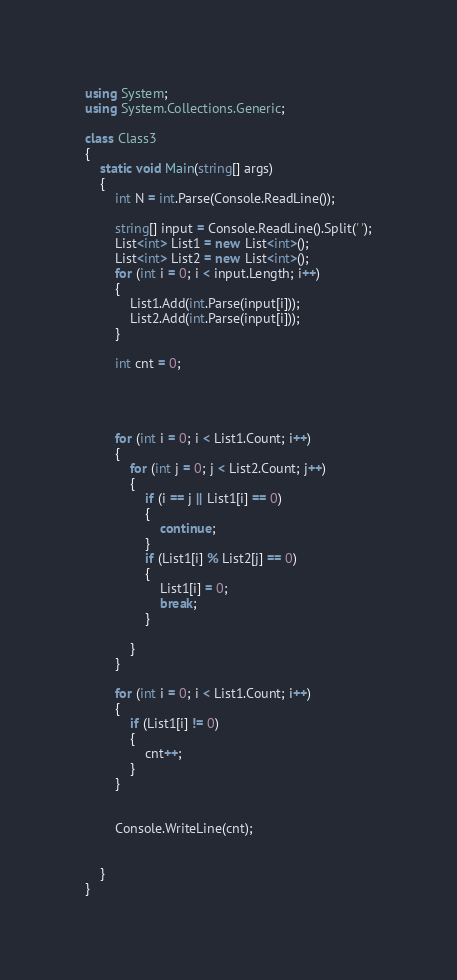Convert code to text. <code><loc_0><loc_0><loc_500><loc_500><_C#_>using System;
using System.Collections.Generic;

class Class3
{
    static void Main(string[] args)
    {
        int N = int.Parse(Console.ReadLine());

        string[] input = Console.ReadLine().Split(' ');
        List<int> List1 = new List<int>();
        List<int> List2 = new List<int>();
        for (int i = 0; i < input.Length; i++)
        {
            List1.Add(int.Parse(input[i]));
            List2.Add(int.Parse(input[i]));
        }

        int cnt = 0;




        for (int i = 0; i < List1.Count; i++)
        {
            for (int j = 0; j < List2.Count; j++)
            {
                if (i == j || List1[i] == 0)
                {
                    continue;
                }
                if (List1[i] % List2[j] == 0)
                {
                    List1[i] = 0;
                    break;
                }

            }
        }

        for (int i = 0; i < List1.Count; i++)
        {
            if (List1[i] != 0)
            {
                cnt++;
            }
        }


        Console.WriteLine(cnt);


    }
}
</code> 